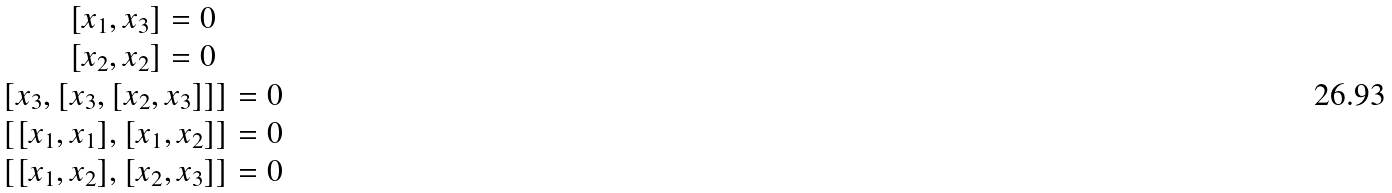<formula> <loc_0><loc_0><loc_500><loc_500>\begin{matrix} { { [ x _ { 1 } , x _ { 3 } ] } = 0 } \\ { { [ x _ { 2 } , x _ { 2 } ] } = 0 } \\ { { [ x _ { 3 } , [ x _ { 3 } , [ x _ { 2 } , x _ { 3 } ] ] ] } = 0 } \\ { { [ [ x _ { 1 } , x _ { 1 } ] , [ x _ { 1 } , x _ { 2 } ] ] } = 0 } \\ { { [ [ x _ { 1 } , x _ { 2 } ] , [ x _ { 2 } , x _ { 3 } ] ] } = 0 } \end{matrix}</formula> 